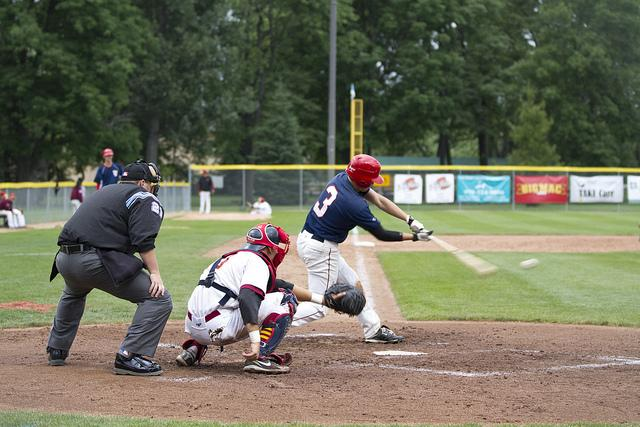What happens in the ball goes over the yellow barrier? Please explain your reasoning. home run. That will be a goal. 